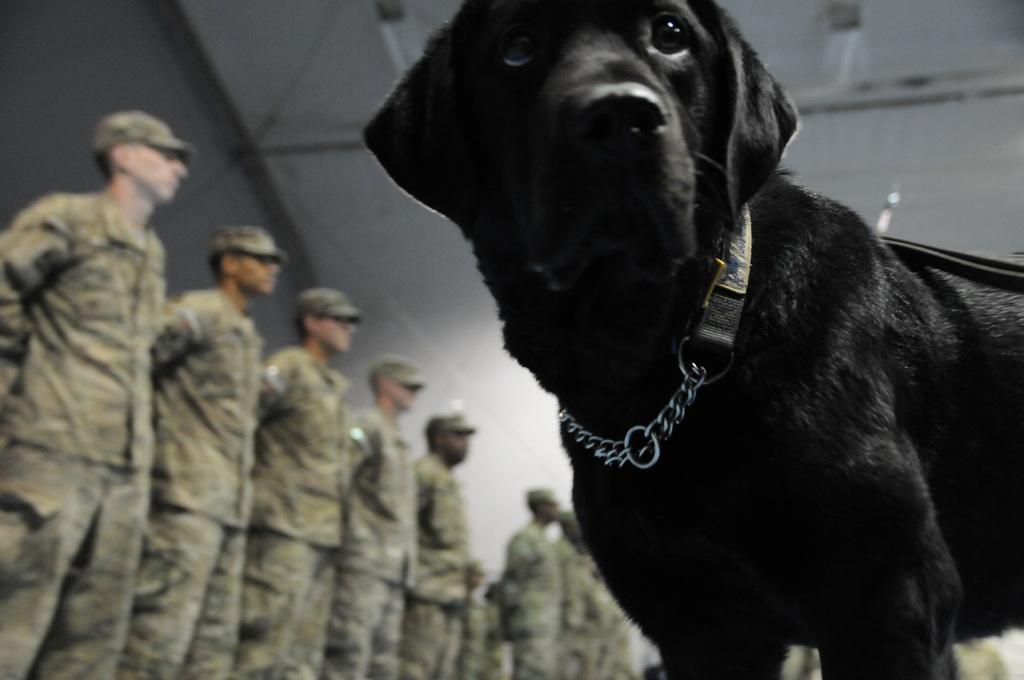Could you give a brief overview of what you see in this image? This image consists of a black dog. It has a belt. There are so many people standing. They are wearing military dresses. 